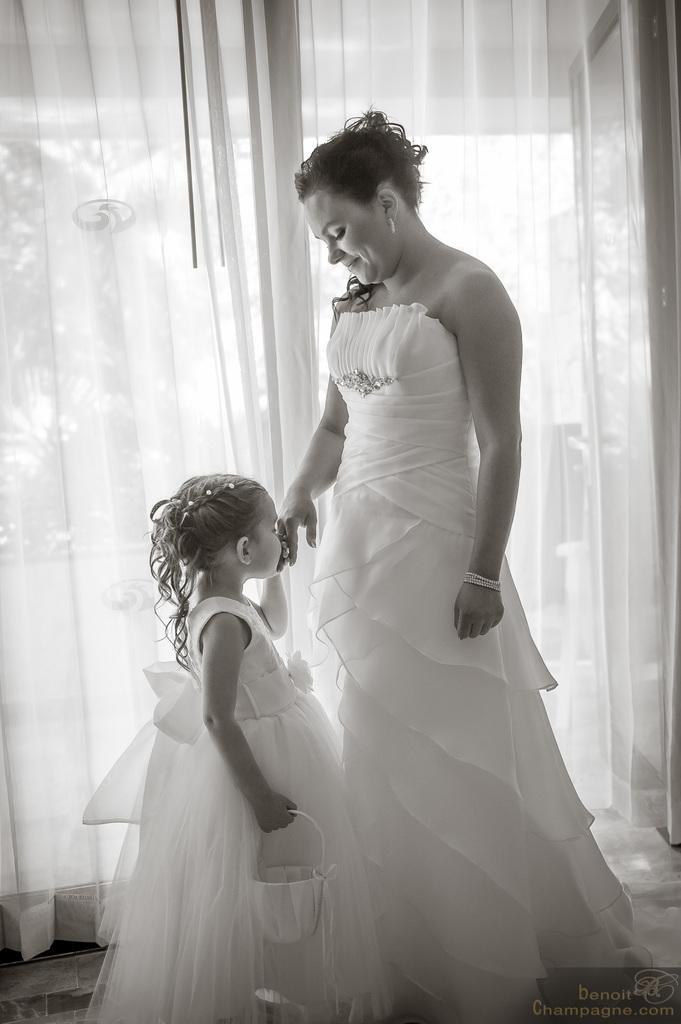Could you give a brief overview of what you see in this image? In this picture I can observe a woman and girl in the middle of the picture. In the background I can observe curtain. This is a black and white image. 